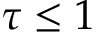Convert formula to latex. <formula><loc_0><loc_0><loc_500><loc_500>\tau \leq 1</formula> 